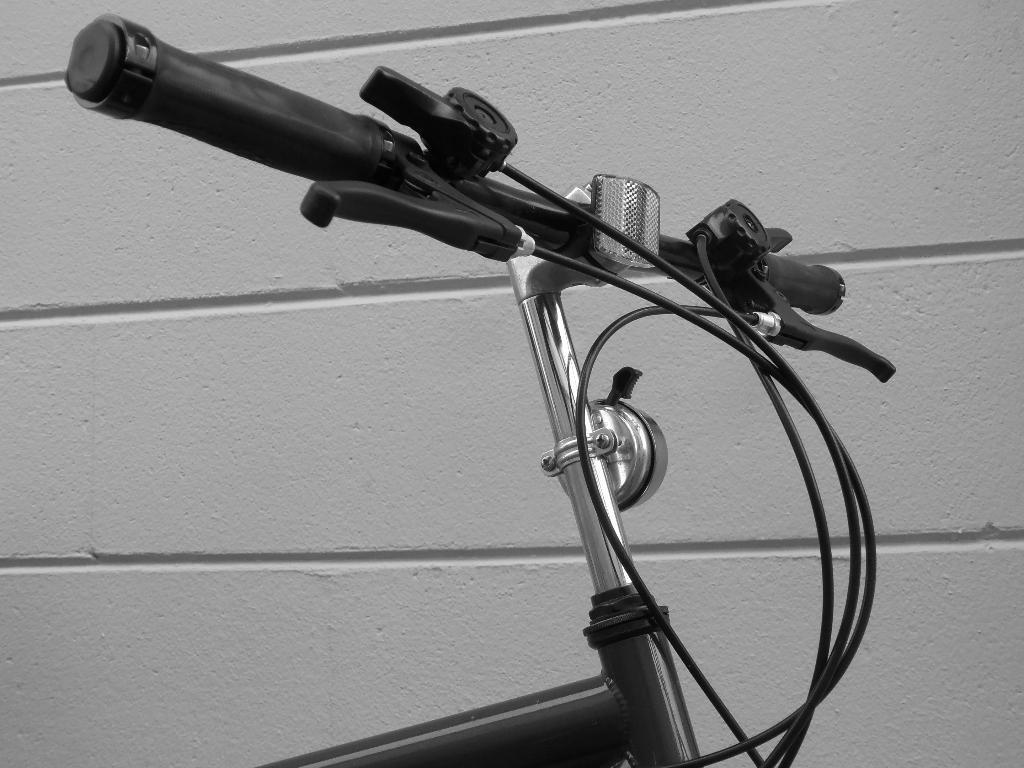Could you give a brief overview of what you see in this image? In this image we can see the front part of the bicycle. In the background there is a wall. 